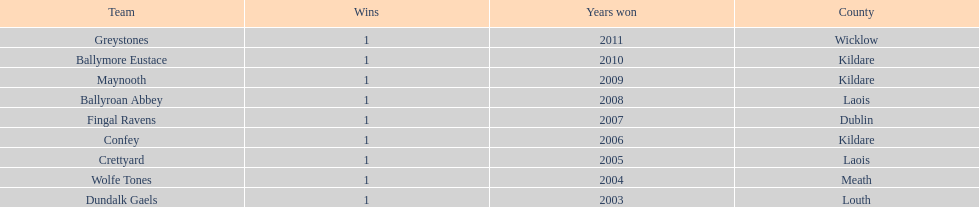Which team won previous to crettyard? Wolfe Tones. 